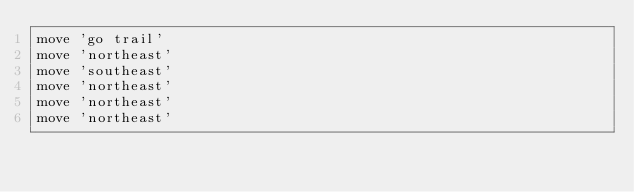<code> <loc_0><loc_0><loc_500><loc_500><_Ruby_>move 'go trail'
move 'northeast'
move 'southeast'
move 'northeast'
move 'northeast'
move 'northeast'</code> 